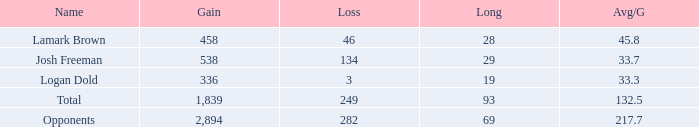Which average per game (avg/g) has an increase of 1,839? 132.5. 